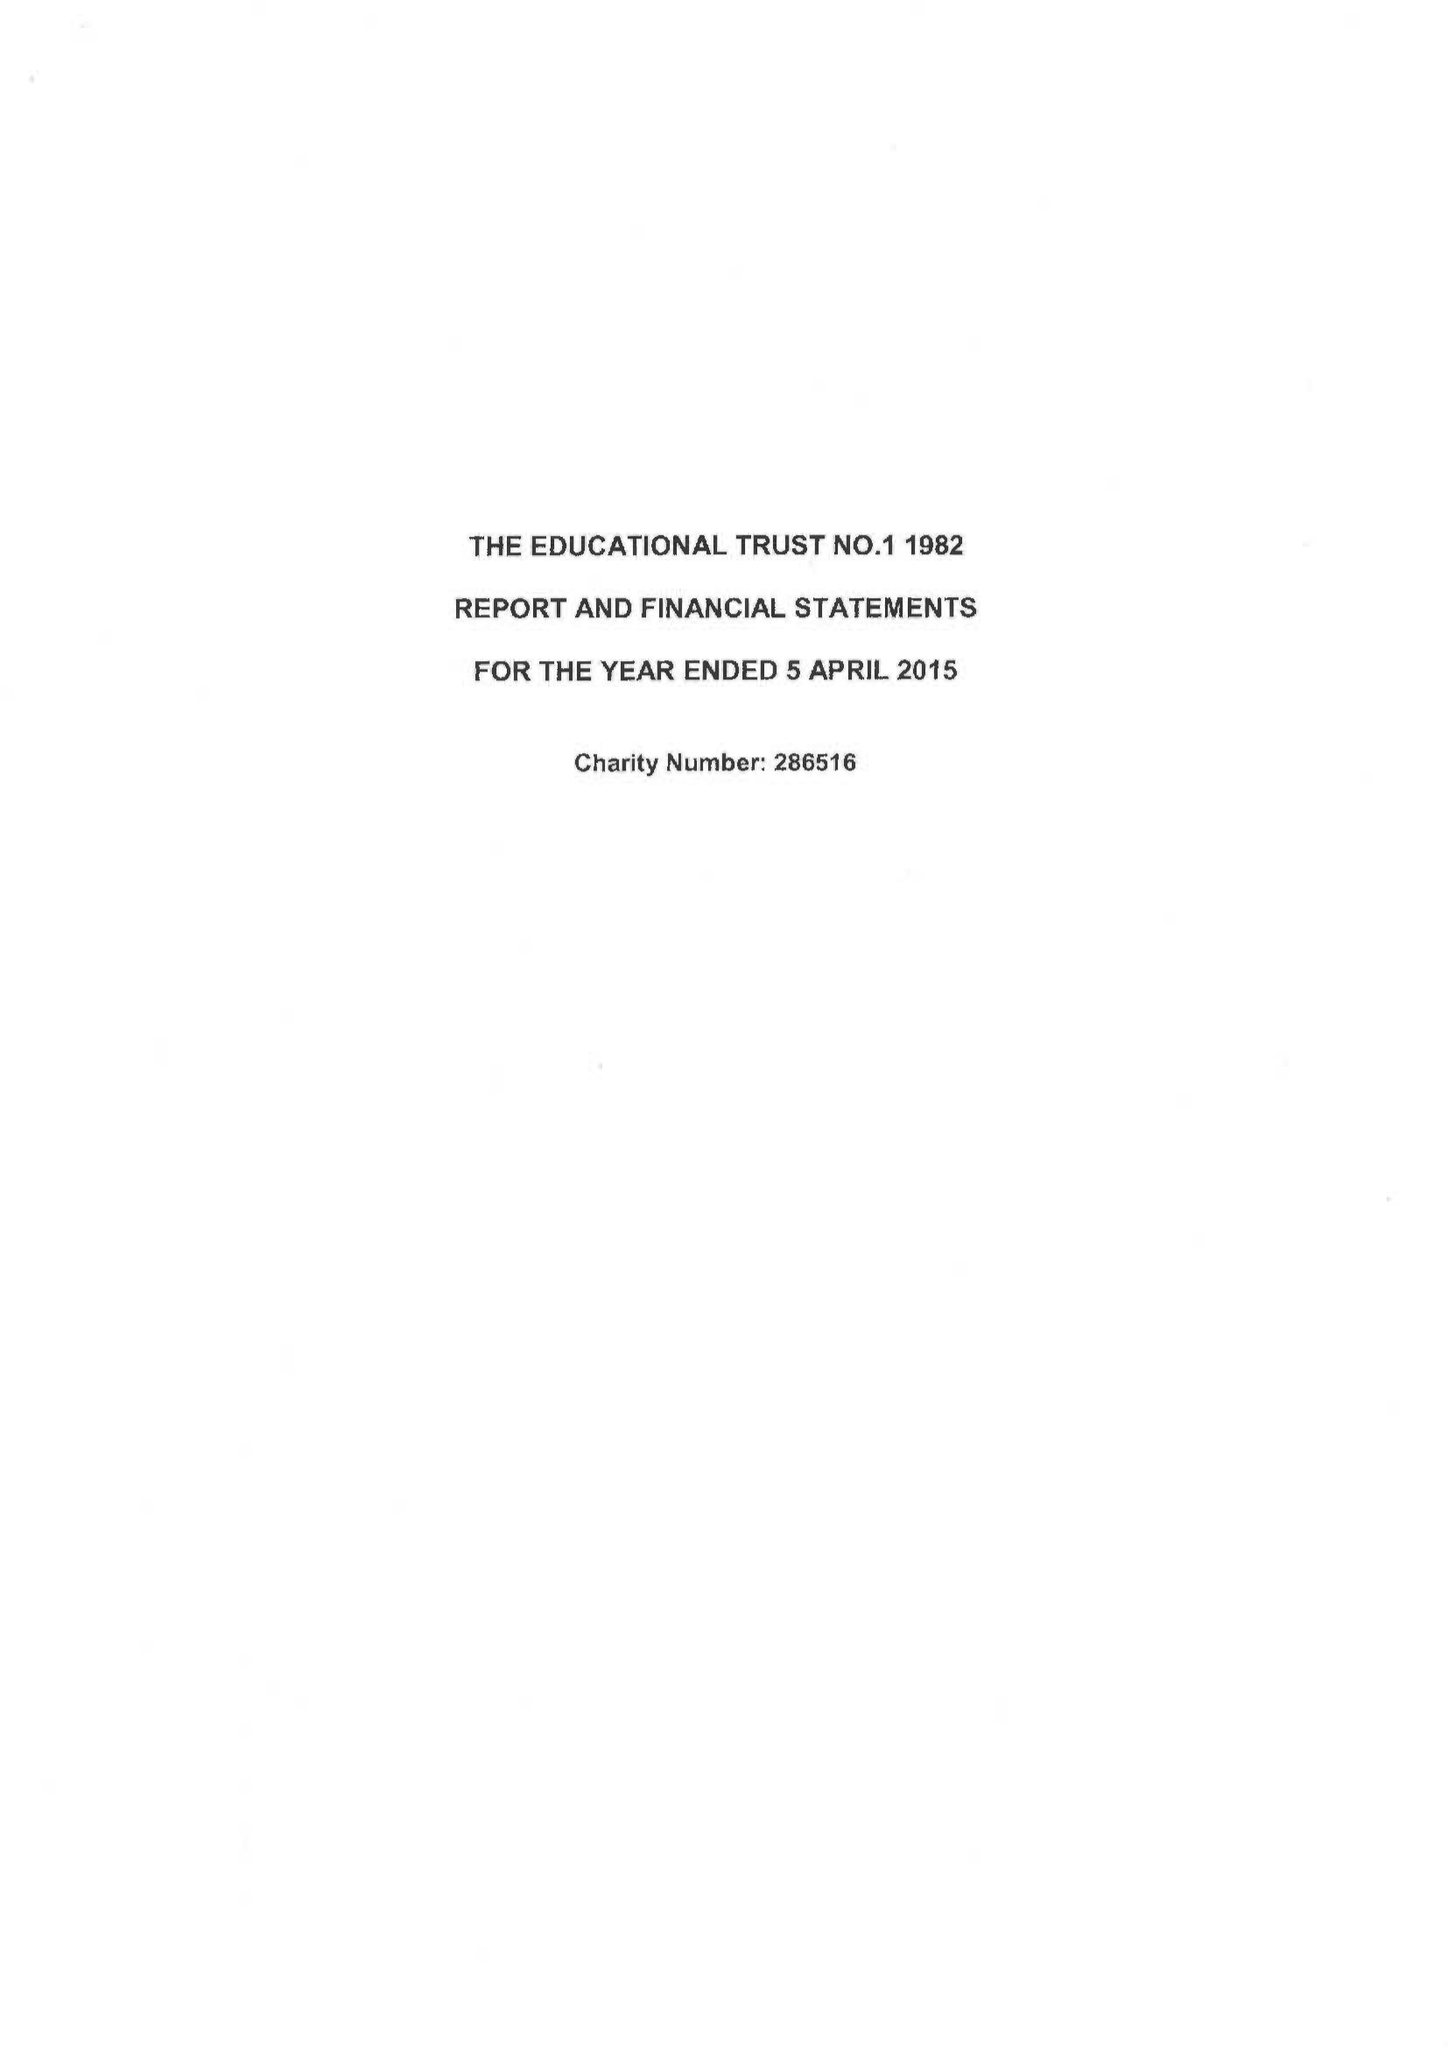What is the value for the income_annually_in_british_pounds?
Answer the question using a single word or phrase. 63065.00 